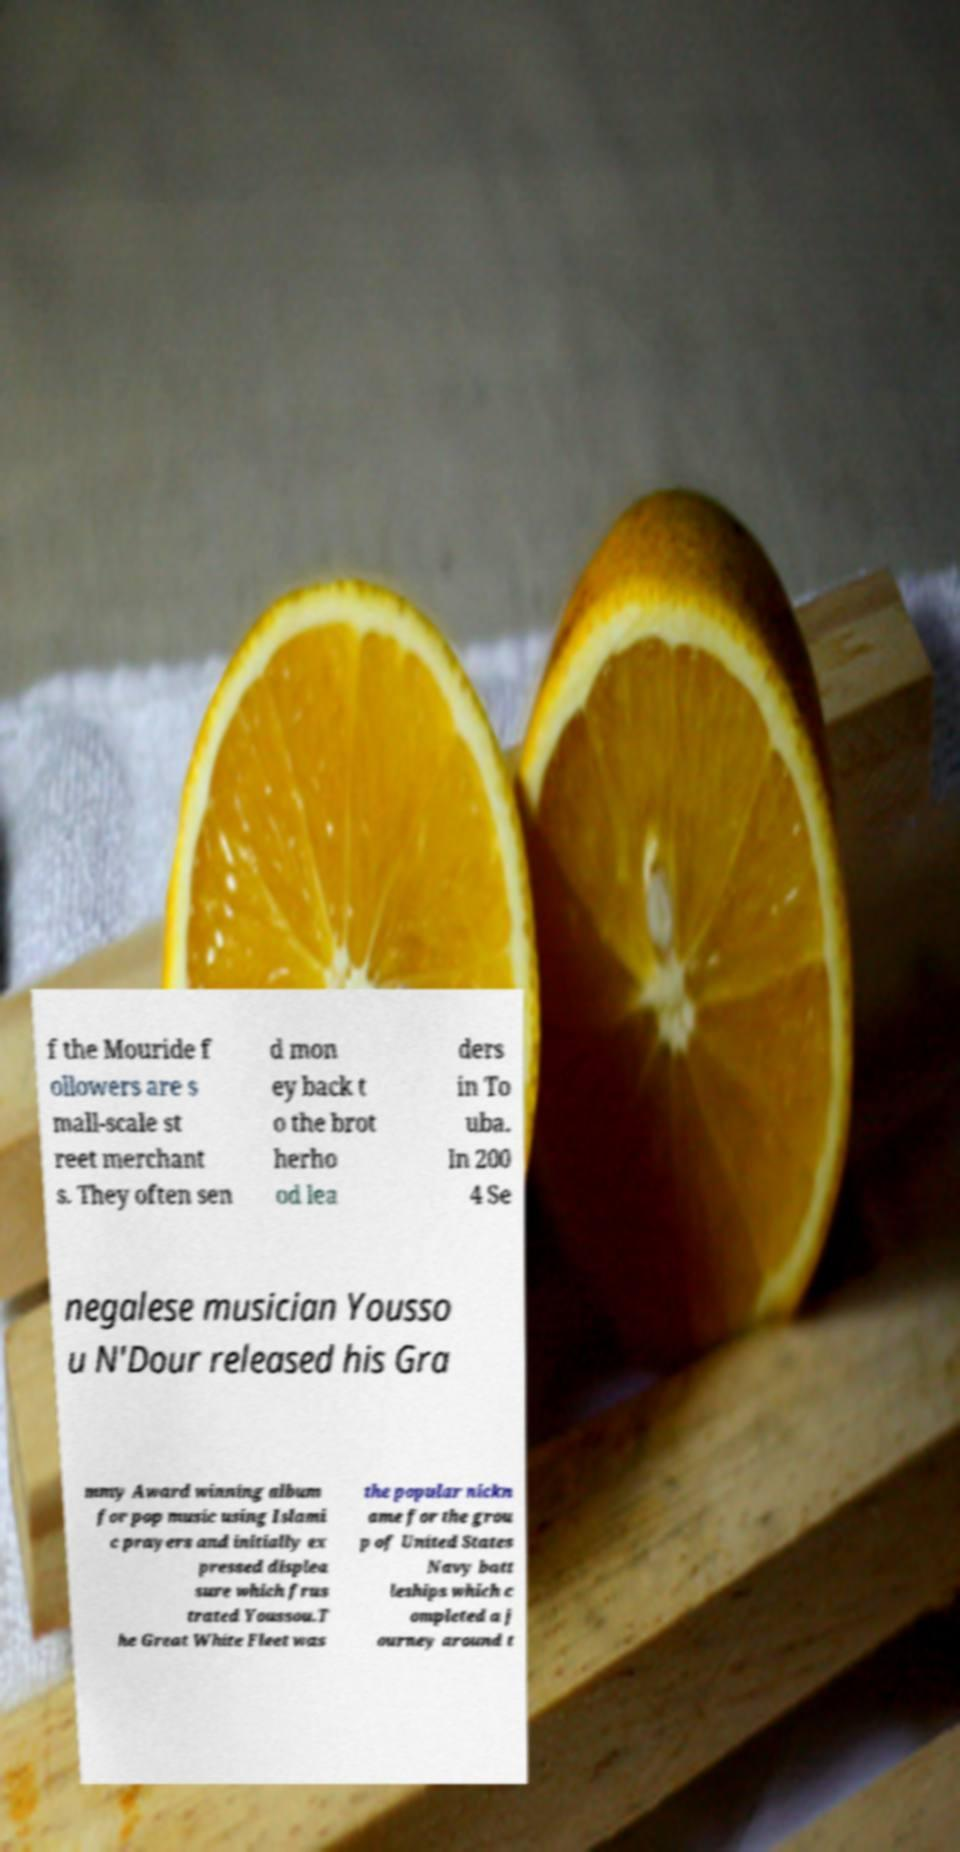Please identify and transcribe the text found in this image. f the Mouride f ollowers are s mall-scale st reet merchant s. They often sen d mon ey back t o the brot herho od lea ders in To uba. In 200 4 Se negalese musician Yousso u N'Dour released his Gra mmy Award winning album for pop music using Islami c prayers and initially ex pressed displea sure which frus trated Youssou.T he Great White Fleet was the popular nickn ame for the grou p of United States Navy batt leships which c ompleted a j ourney around t 